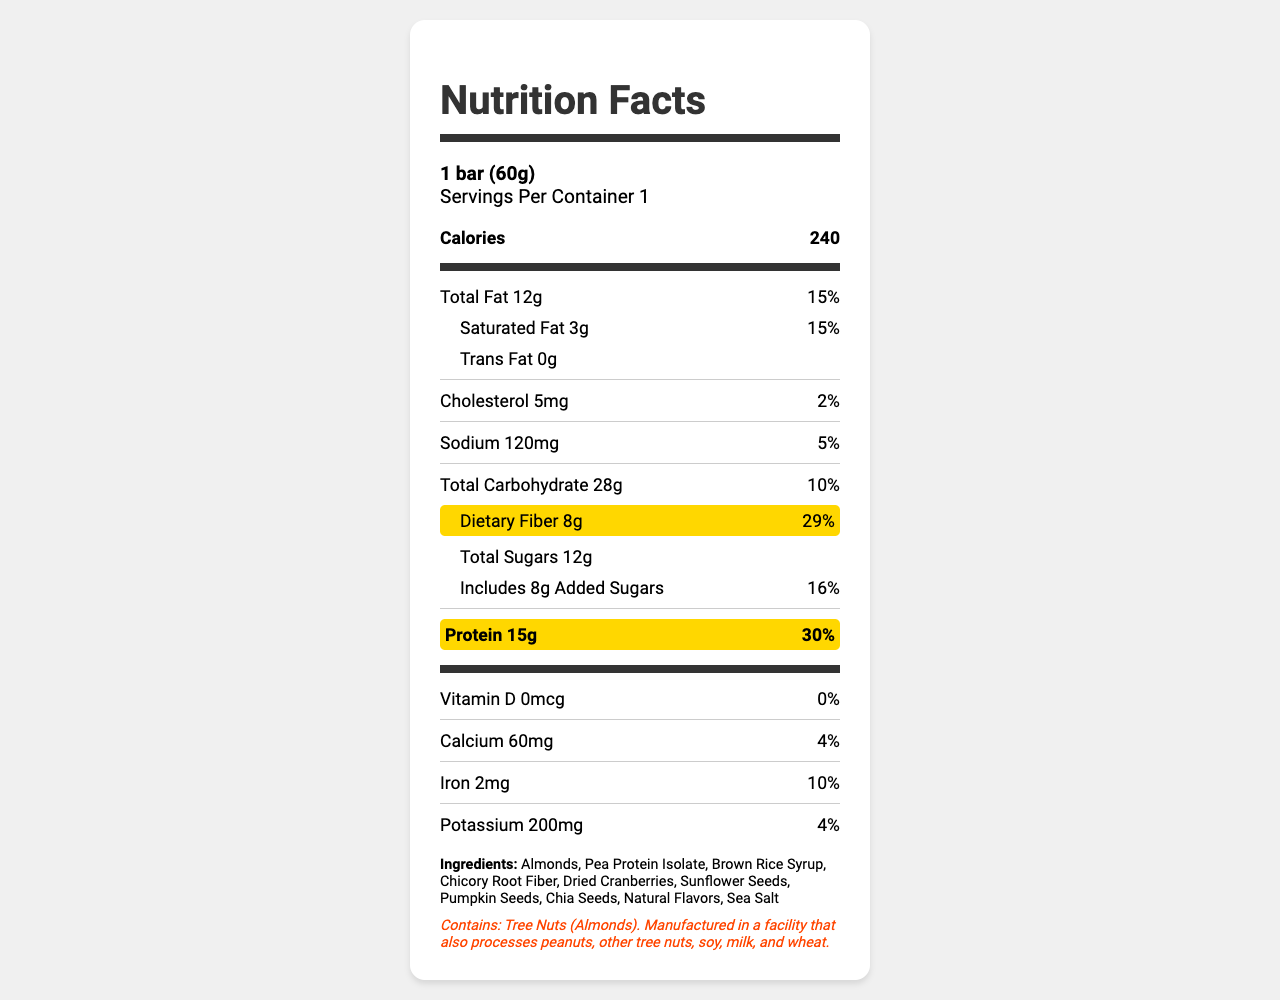what is the serving size of the PowerPro Gourmet Energy Bar? The serving size is stated at the top of the Nutrition Facts label: "1 bar (60g)".
Answer: 1 bar (60g) how many grams of protein are in one serving of the PowerPro Gourmet Energy Bar? The protein content is highlighted and listed as "15g".
Answer: 15g how many grams of dietary fiber does the PowerPro Gourmet Energy Bar contain? The dietary fiber content is highlighted and stated as "8g".
Answer: 8g what is the daily value percentage of protein in one serving? The daily value percentage for protein is listed as "30%" next to the protein content.
Answer: 30% what is the calorie content of the PowerPro Gourmet Energy Bar? Calories are listed at the top as "240".
Answer: 240 how many grams of total carbohydrates are in the PowerPro Gourmet Energy Bar? Total carbohydrates are listed as "28g" on the Nutrition Facts label.
Answer: 28g how many grams of added sugars are in the PowerPro Gourmet Energy Bar? The amount of added sugars is stated as "8g" next to the total sugars content.
Answer: 8g which of the following best describes the allergen information provided? A. Contains dairy and gluten B. Contains tree nuts and manufactured in a facility with peanuts C. Contains soy and fish The allergen information states: "Contains: Tree Nuts (Almonds). Manufactured in a facility that also processes peanuts, other tree nuts, soy, milk, and wheat."
Answer: B which mineral in the PowerPro Gourmet Energy Bar has the highest daily value percentage? A. Calcium B. Iron C. Potassium D. Sodium The iron content has a daily value of 10%, higher compared to calcium (4%), potassium (4%), and sodium (5%).
Answer: B is the vitamin D content in the PowerPro Gourmet Energy Bar significant? The vitamin D content is listed as "0mcg" with a daily value of "0%", indicating it is not significant.
Answer: No what is the main focus of the Nutrition Facts label for the PowerPro Gourmet Energy Bar? The main idea of the document is to inform consumers about the nutritional content of the PowerPro Gourmet Energy Bar, emphasizing its key selling points like high protein and fiber content.
Answer: The label provides detailed nutritional information about the bar, highlighting its high protein and dietary fiber content. It includes amounts of fats, carbohydrates, sugars, vitamins, and minerals per serving and provides daily value percentages. how many vitamins are listed on the Nutrition Facts label? The only vitamin listed is Vitamin D.
Answer: 1 what is the serving size of the container? The document doesn't provide any information about the serving size of the container beyond noting that there is 1 serving per container.
Answer: Cannot be determined 